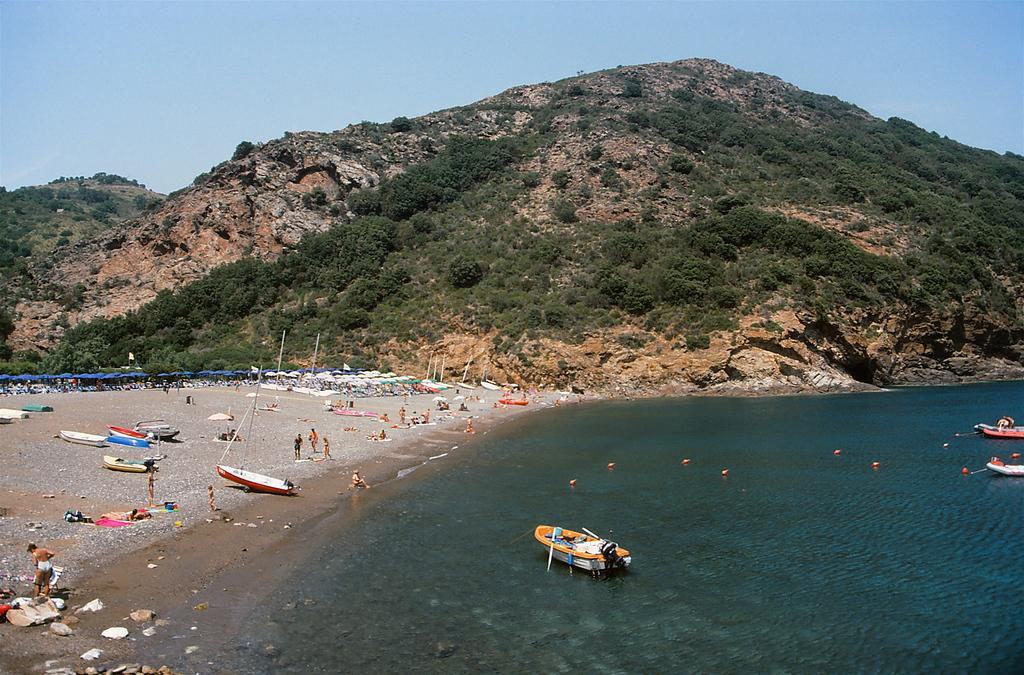What can be seen in the sky in the image? The sky is visible in the image. What type of landscape is depicted in the image? There are hills and trees in the image. What body of water is present in the image? Ships are in the sea in the image. What objects are used for shade in the image? Parasols are in the image. What are the people in the image doing? Persons are sitting and standing on the sea shore in the image. Where is the cemetery located in the image? There is no cemetery present in the image. What type of trade is happening between the ships in the image? There is no indication of trade between the ships in the image. What is the person holding in the image to control the horses? There are no horses or whips present in the image. 